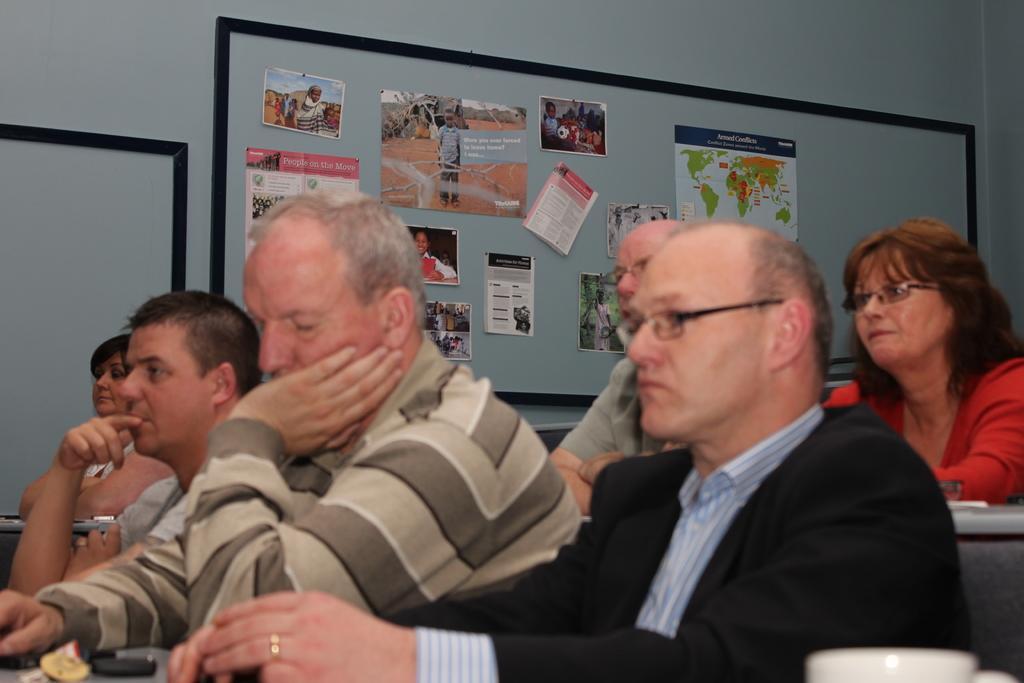How would you summarize this image in a sentence or two? In this picture i can see few people seated and I can see paper on the table and few of them wore spectacles and few posters on the board and I can see another board on the side. 